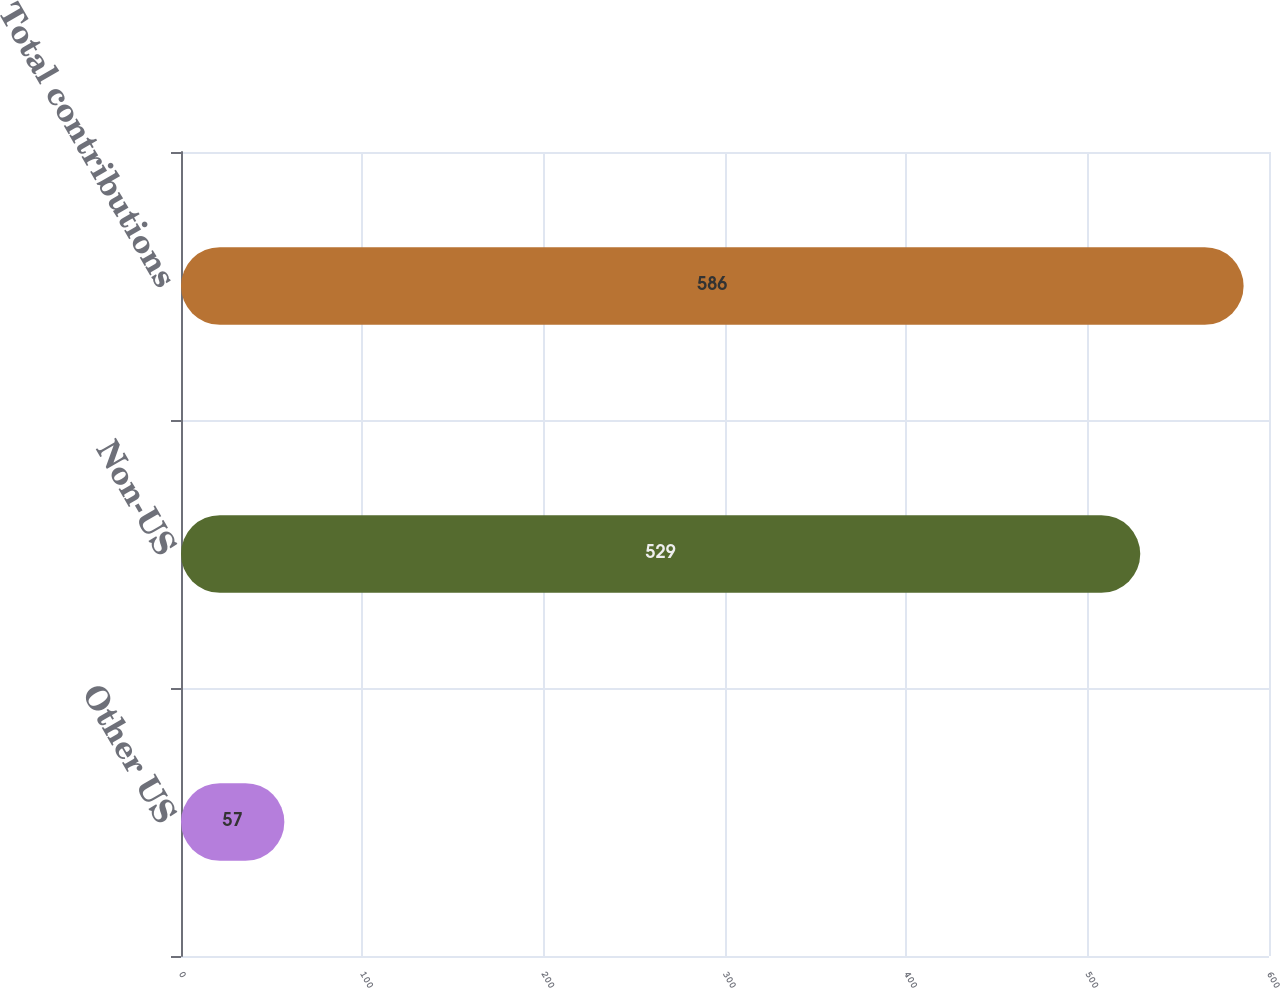Convert chart to OTSL. <chart><loc_0><loc_0><loc_500><loc_500><bar_chart><fcel>Other US<fcel>Non-US<fcel>Total contributions<nl><fcel>57<fcel>529<fcel>586<nl></chart> 